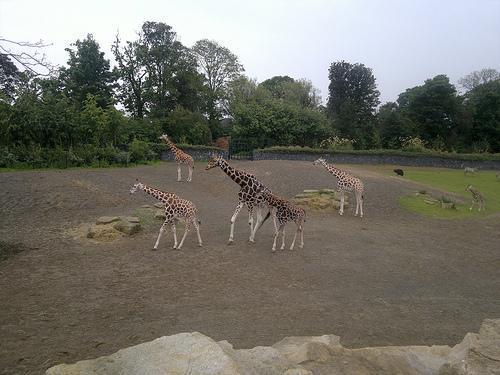How many giraffes are there?
Give a very brief answer. 6. 